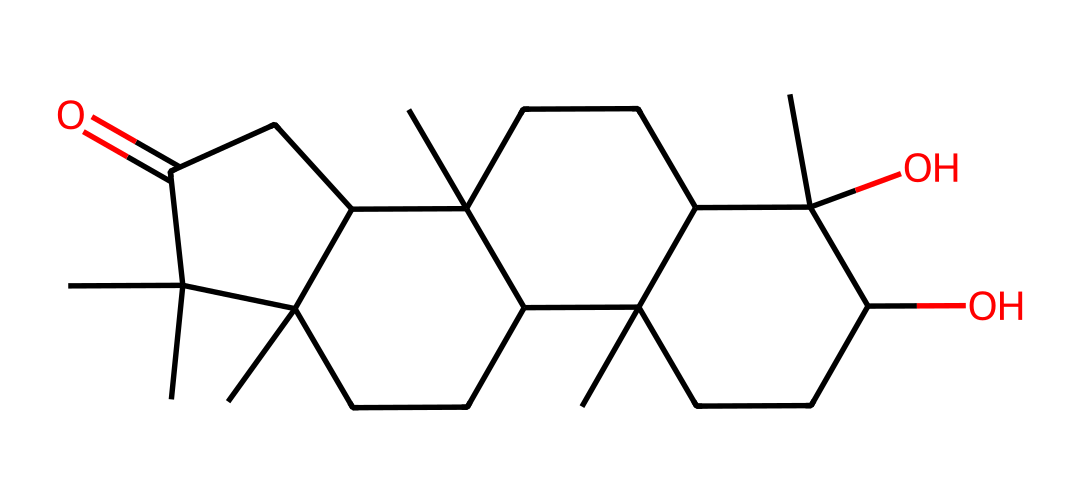What is the primary carbon skeleton shape of this compound? The compound features a complex bicyclic structure with multiple connected carbon chains. The visual representation reveals a predominantly fused ring system.
Answer: bicyclic How many hydroxyl groups (–OH) are present in the structure? Upon analyzing the structure, there are two distinct hydroxyl groups attached at different positions of the carbon framework. Each –OH adds to the potential for interactions with other molecules.
Answer: 2 Does this chemical contain any double bonds? The examination of the SMILES shows that all carbon atoms are connected by single bonds with no visual representation of double bonds, indicating no unsaturation in this particular structure.
Answer: no What kind of aroma does this chemical typically evoke? This compound is well-known as patchouli oil, which is recognized for its deep, earthy, and musky scent. The combination of its structural components contributes to its distinctive fragrance profile.
Answer: earthy Is this chemical commonly used in perfumery? Given its well-established presence in fragrance formulations and its characteristic scent, this compound is indeed frequently used in perfumes and scented products.
Answer: yes What is the number of rings present in the structure? By assessing the structural connections, it becomes evident that there are three rings integrated within the overall molecular architecture, contributing to its complexity.
Answer: 3 